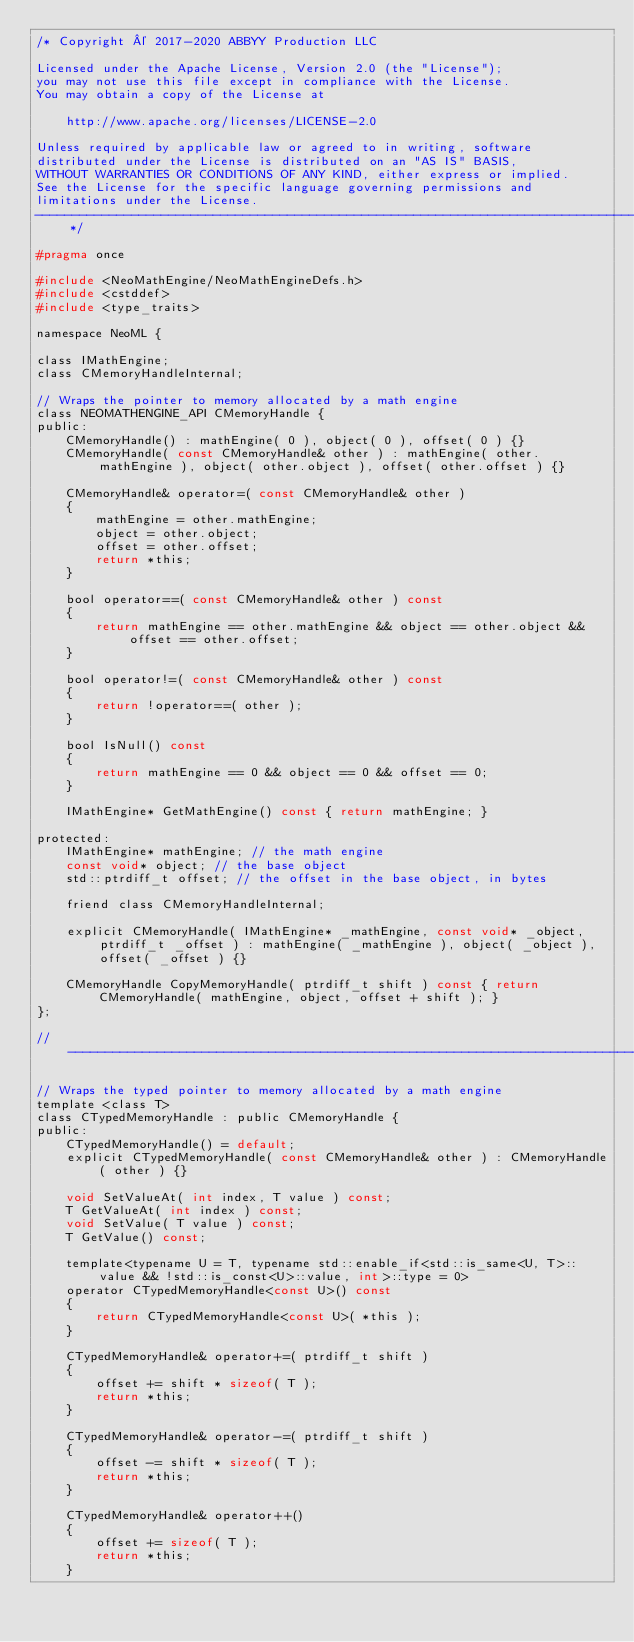Convert code to text. <code><loc_0><loc_0><loc_500><loc_500><_C_>/* Copyright © 2017-2020 ABBYY Production LLC

Licensed under the Apache License, Version 2.0 (the "License");
you may not use this file except in compliance with the License.
You may obtain a copy of the License at

	http://www.apache.org/licenses/LICENSE-2.0

Unless required by applicable law or agreed to in writing, software
distributed under the License is distributed on an "AS IS" BASIS,
WITHOUT WARRANTIES OR CONDITIONS OF ANY KIND, either express or implied.
See the License for the specific language governing permissions and
limitations under the License.
--------------------------------------------------------------------------------------------------------------*/

#pragma once

#include <NeoMathEngine/NeoMathEngineDefs.h>
#include <cstddef>
#include <type_traits>

namespace NeoML {

class IMathEngine;
class CMemoryHandleInternal;

// Wraps the pointer to memory allocated by a math engine
class NEOMATHENGINE_API CMemoryHandle {
public:
	CMemoryHandle() : mathEngine( 0 ), object( 0 ), offset( 0 ) {}
	CMemoryHandle( const CMemoryHandle& other ) : mathEngine( other.mathEngine ), object( other.object ), offset( other.offset ) {}

	CMemoryHandle& operator=( const CMemoryHandle& other )
	{
		mathEngine = other.mathEngine;
		object = other.object;
		offset = other.offset;
		return *this;
	}

	bool operator==( const CMemoryHandle& other ) const
	{
		return mathEngine == other.mathEngine && object == other.object && offset == other.offset;
	}

	bool operator!=( const CMemoryHandle& other ) const
	{
		return !operator==( other );
	}

	bool IsNull() const
	{
		return mathEngine == 0 && object == 0 && offset == 0;
	}

	IMathEngine* GetMathEngine() const { return mathEngine; }

protected:
	IMathEngine* mathEngine; // the math engine
	const void* object; // the base object
	std::ptrdiff_t offset; // the offset in the base object, in bytes

	friend class CMemoryHandleInternal;

	explicit CMemoryHandle( IMathEngine* _mathEngine, const void* _object, ptrdiff_t _offset ) : mathEngine( _mathEngine ), object( _object ), offset( _offset ) {}

	CMemoryHandle CopyMemoryHandle( ptrdiff_t shift ) const { return CMemoryHandle( mathEngine, object, offset + shift ); }
};

//------------------------------------------------------------------------------------------------------------

// Wraps the typed pointer to memory allocated by a math engine
template <class T>
class CTypedMemoryHandle : public CMemoryHandle {
public:
	CTypedMemoryHandle() = default;
	explicit CTypedMemoryHandle( const CMemoryHandle& other ) : CMemoryHandle( other ) {}

	void SetValueAt( int index, T value ) const;
	T GetValueAt( int index ) const;
	void SetValue( T value ) const;
	T GetValue() const;

	template<typename U = T, typename std::enable_if<std::is_same<U, T>::value && !std::is_const<U>::value, int>::type = 0>
	operator CTypedMemoryHandle<const U>() const
	{
		return CTypedMemoryHandle<const U>( *this );
	}

	CTypedMemoryHandle& operator+=( ptrdiff_t shift )
	{
		offset += shift * sizeof( T );
		return *this;
	}

	CTypedMemoryHandle& operator-=( ptrdiff_t shift )
	{
		offset -= shift * sizeof( T );
		return *this;
	}

	CTypedMemoryHandle& operator++()
	{
		offset += sizeof( T );
		return *this;
	}
</code> 